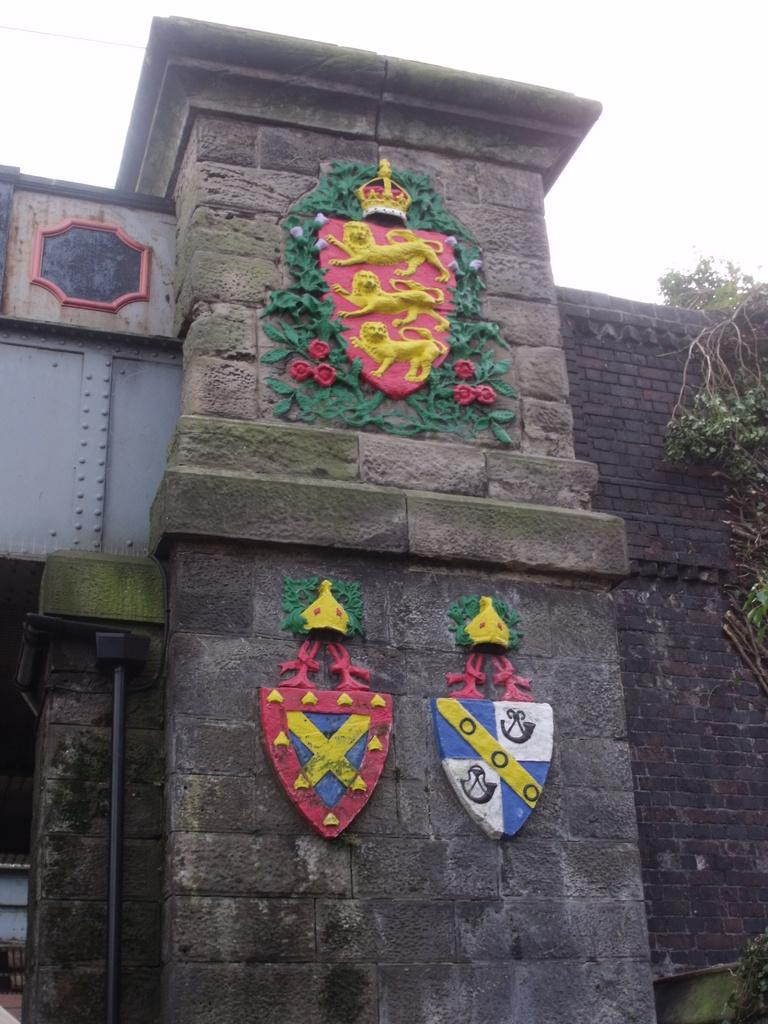What type of structure is shown in the image? There is an old building wall in the image. Can you describe any specific features of the building wall? The building wall has architectural features. What type of vegetation can be seen in the image? There is a part of a plant visible in the image. What part of the sky is visible in the image? The sky is partially visible in the image. What type of shelf can be seen in the image? There is no shelf present in the image. How is the kettle being used in the image? There is no kettle present in the image. 